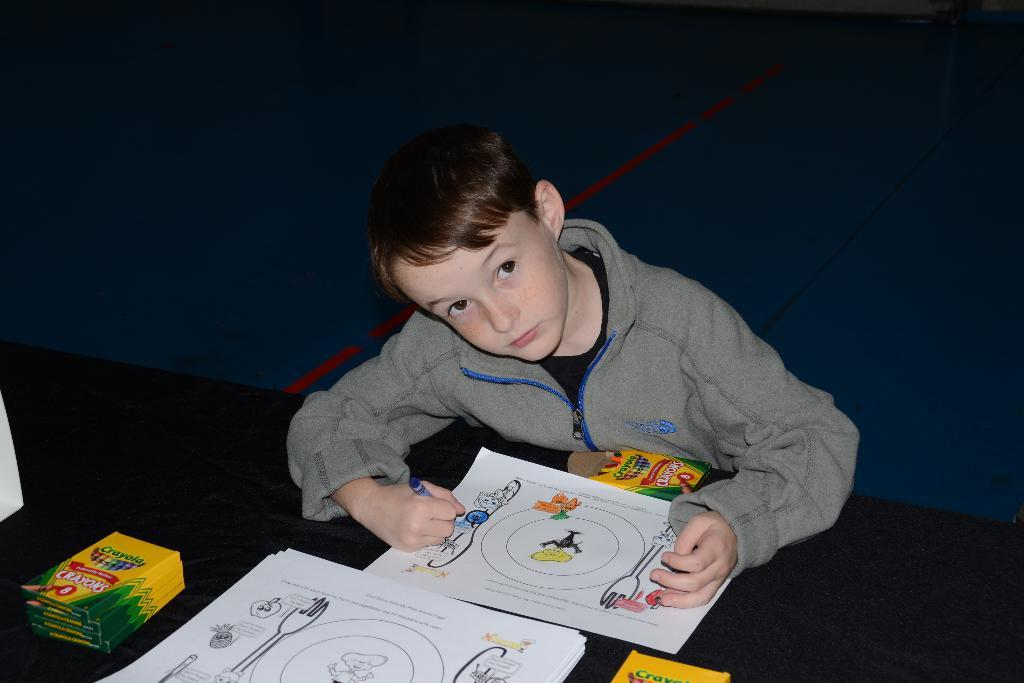What is the main piece of furniture in the image? There is a table in the image. What is on the table in the image? The table contains papers and sketch boxes. Who is present in the image? There is a kid in the image. What is the kid wearing? The kid is wearing clothes. What is the kid doing in the image? The kid is coloring a picture. Can you tell me what type of drain is visible in the image? There is no drain present in the image. What kind of play equipment can be seen in the image? There is no play equipment visible in the image. 